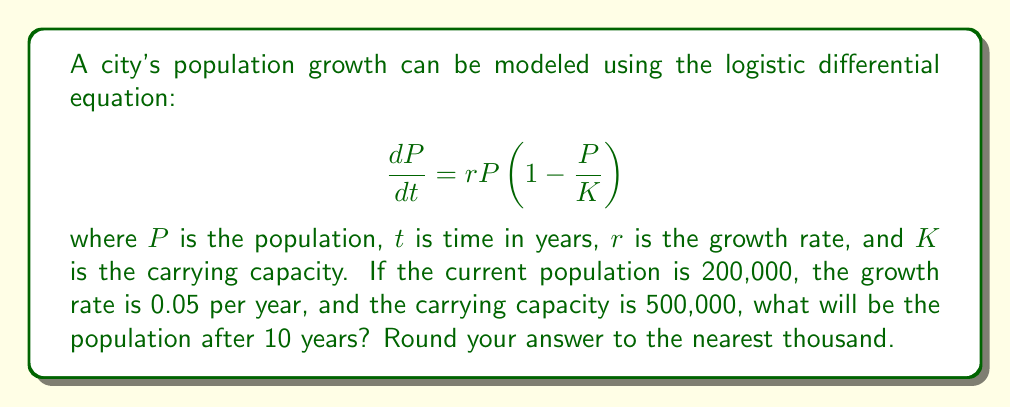Help me with this question. To solve this problem, we'll use the logistic growth formula:

$$P(t) = \frac{K}{1 + (\frac{K}{P_0} - 1)e^{-rt}}$$

Where:
$P(t)$ is the population at time $t$
$K$ is the carrying capacity (500,000)
$P_0$ is the initial population (200,000)
$r$ is the growth rate (0.05)
$t$ is the time in years (10)

Let's substitute these values into the equation:

$$P(10) = \frac{500,000}{1 + (\frac{500,000}{200,000} - 1)e^{-0.05 \cdot 10}}$$

$$= \frac{500,000}{1 + (2.5 - 1)e^{-0.5}}$$

$$= \frac{500,000}{1 + 1.5e^{-0.5}}$$

$$= \frac{500,000}{1 + 1.5 \cdot 0.6065}$$

$$= \frac{500,000}{1.9098}$$

$$= 261,808$$

Rounding to the nearest thousand:

$$P(10) \approx 262,000$$
Answer: 262,000 